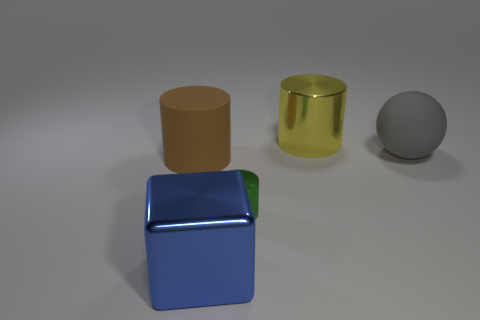What is the object that is behind the large matte object on the right side of the tiny metallic cylinder made of?
Your answer should be compact. Metal. What number of other objects are there of the same shape as the tiny green thing?
Your answer should be very brief. 2. There is a big shiny thing that is to the left of the big yellow metal thing; is it the same shape as the metallic object that is behind the small metal cylinder?
Your response must be concise. No. What material is the big sphere?
Your answer should be very brief. Rubber. What material is the large cylinder in front of the gray rubber thing?
Make the answer very short. Rubber. What is the size of the yellow cylinder that is made of the same material as the cube?
Ensure brevity in your answer.  Large. What number of large objects are either green metal objects or green balls?
Offer a terse response. 0. How big is the metallic cylinder behind the large matte thing to the right of the matte object that is to the left of the big blue shiny object?
Ensure brevity in your answer.  Large. How many cyan cubes are the same size as the gray matte ball?
Your answer should be compact. 0. How many things are either big brown matte cylinders or cylinders behind the green cylinder?
Keep it short and to the point. 2. 